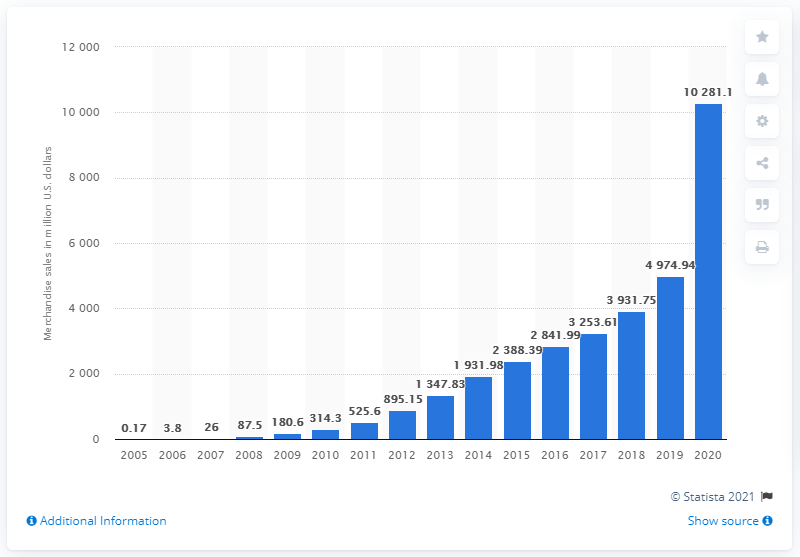What was Etsy's annual merchandise sales volume in dollars in 2020? In 2020, Etsy's annual merchandise sales volume reached approximately $10.28 billion, showcasing a significant increase from the previous year and reflecting the platform's growing popularity among buyers and sellers worldwide. 